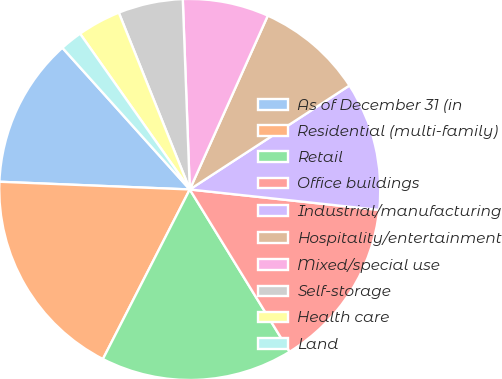Convert chart to OTSL. <chart><loc_0><loc_0><loc_500><loc_500><pie_chart><fcel>As of December 31 (in<fcel>Residential (multi-family)<fcel>Retail<fcel>Office buildings<fcel>Industrial/manufacturing<fcel>Hospitality/entertainment<fcel>Mixed/special use<fcel>Self-storage<fcel>Health care<fcel>Land<nl><fcel>12.7%<fcel>18.11%<fcel>16.31%<fcel>14.51%<fcel>10.9%<fcel>9.1%<fcel>7.3%<fcel>5.49%<fcel>3.69%<fcel>1.89%<nl></chart> 